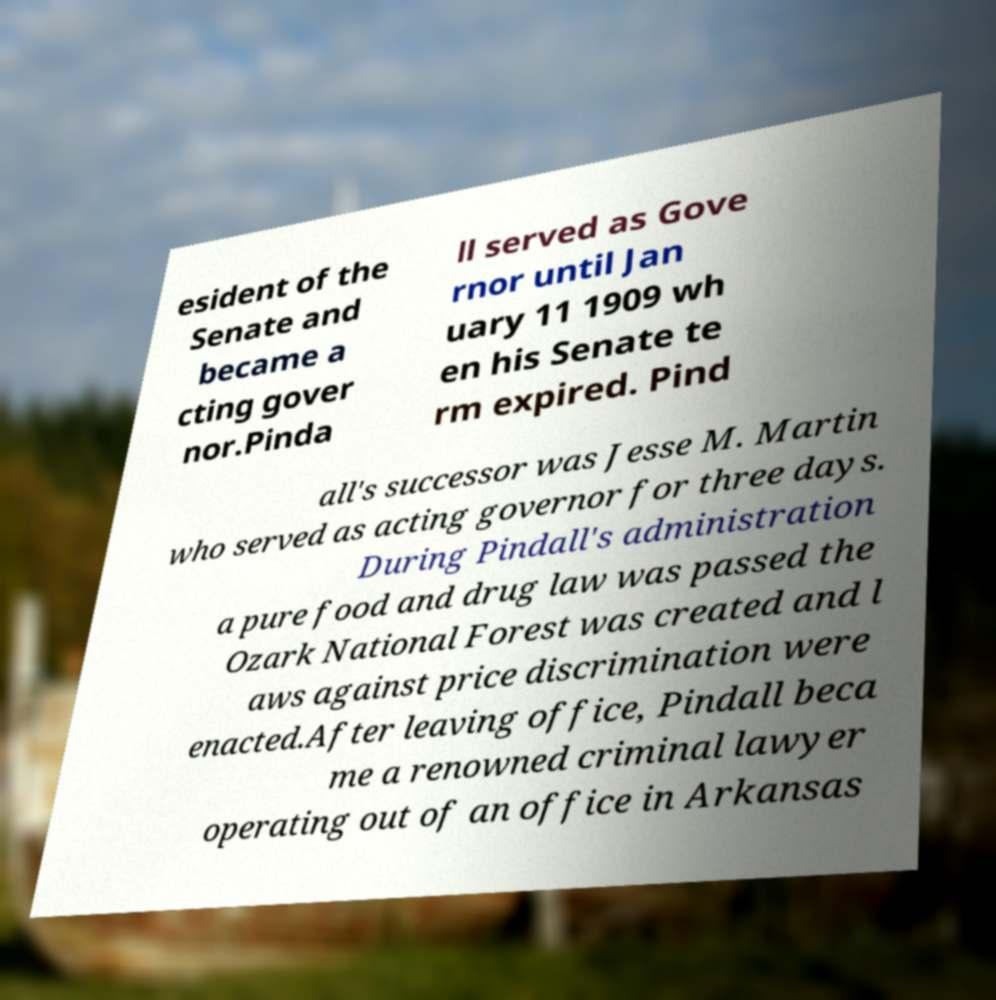Can you accurately transcribe the text from the provided image for me? esident of the Senate and became a cting gover nor.Pinda ll served as Gove rnor until Jan uary 11 1909 wh en his Senate te rm expired. Pind all's successor was Jesse M. Martin who served as acting governor for three days. During Pindall's administration a pure food and drug law was passed the Ozark National Forest was created and l aws against price discrimination were enacted.After leaving office, Pindall beca me a renowned criminal lawyer operating out of an office in Arkansas 